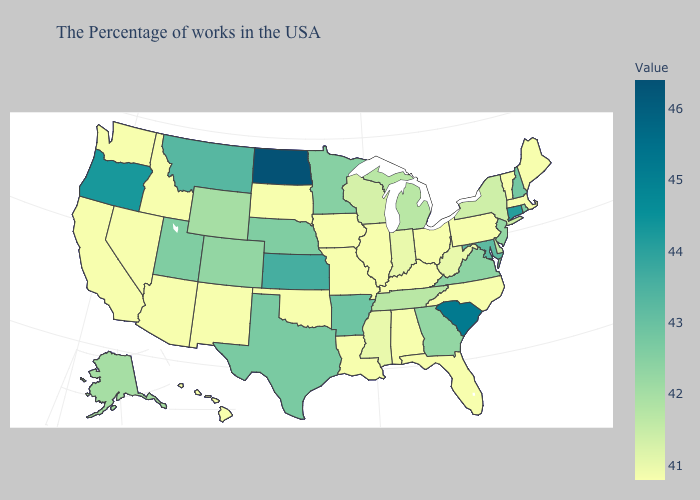Which states have the highest value in the USA?
Be succinct. North Dakota. Among the states that border New Jersey , does New York have the highest value?
Quick response, please. No. Among the states that border Kansas , which have the highest value?
Quick response, please. Nebraska. Which states have the lowest value in the USA?
Answer briefly. Maine, Massachusetts, Vermont, Pennsylvania, North Carolina, Ohio, Florida, Kentucky, Alabama, Illinois, Louisiana, Missouri, Iowa, Oklahoma, South Dakota, New Mexico, Arizona, Idaho, Nevada, California, Washington, Hawaii. Is the legend a continuous bar?
Quick response, please. Yes. Does Rhode Island have the highest value in the USA?
Be succinct. No. 